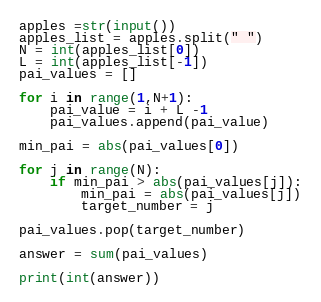Convert code to text. <code><loc_0><loc_0><loc_500><loc_500><_Python_>apples =str(input())
apples_list = apples.split(" ")
N = int(apples_list[0])
L = int(apples_list[-1])
pai_values = []

for i in range(1,N+1):
    pai_value = i + L -1
    pai_values.append(pai_value)

min_pai = abs(pai_values[0])

for j in range(N):
    if min_pai > abs(pai_values[j]):
        min_pai = abs(pai_values[j])
        target_number = j

pai_values.pop(target_number)

answer = sum(pai_values)

print(int(answer))
</code> 